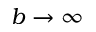<formula> <loc_0><loc_0><loc_500><loc_500>b \to \infty</formula> 